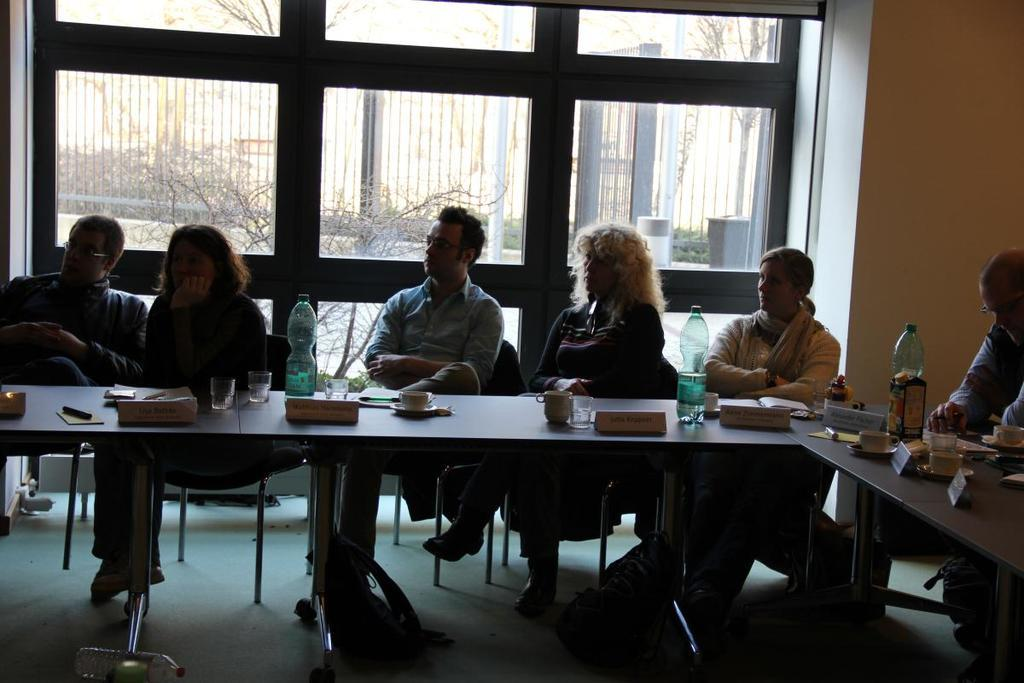What is happening in the image? There are people sitting around a table in the image. What can be seen on the table? There are name plates, bottles, and glasses on the table. What color is the coil used for the holiday decoration in the image? There is no coil or holiday decoration present in the image. 